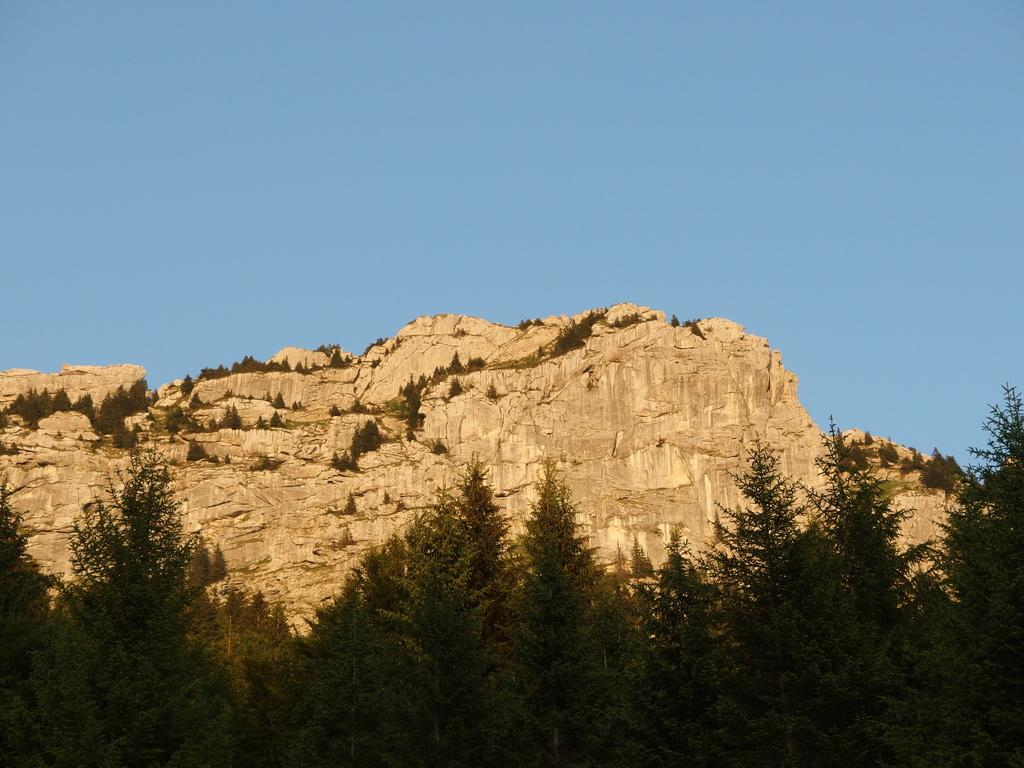What type of landscape can be seen in the image? There are hills in the image. What other natural elements are present in the image? There are trees in the image. What is visible in the background of the image? The sky is visible in the image. What type of bag is being used to copy the jelly in the image? There is no bag, jelly, or copying activity present in the image. 